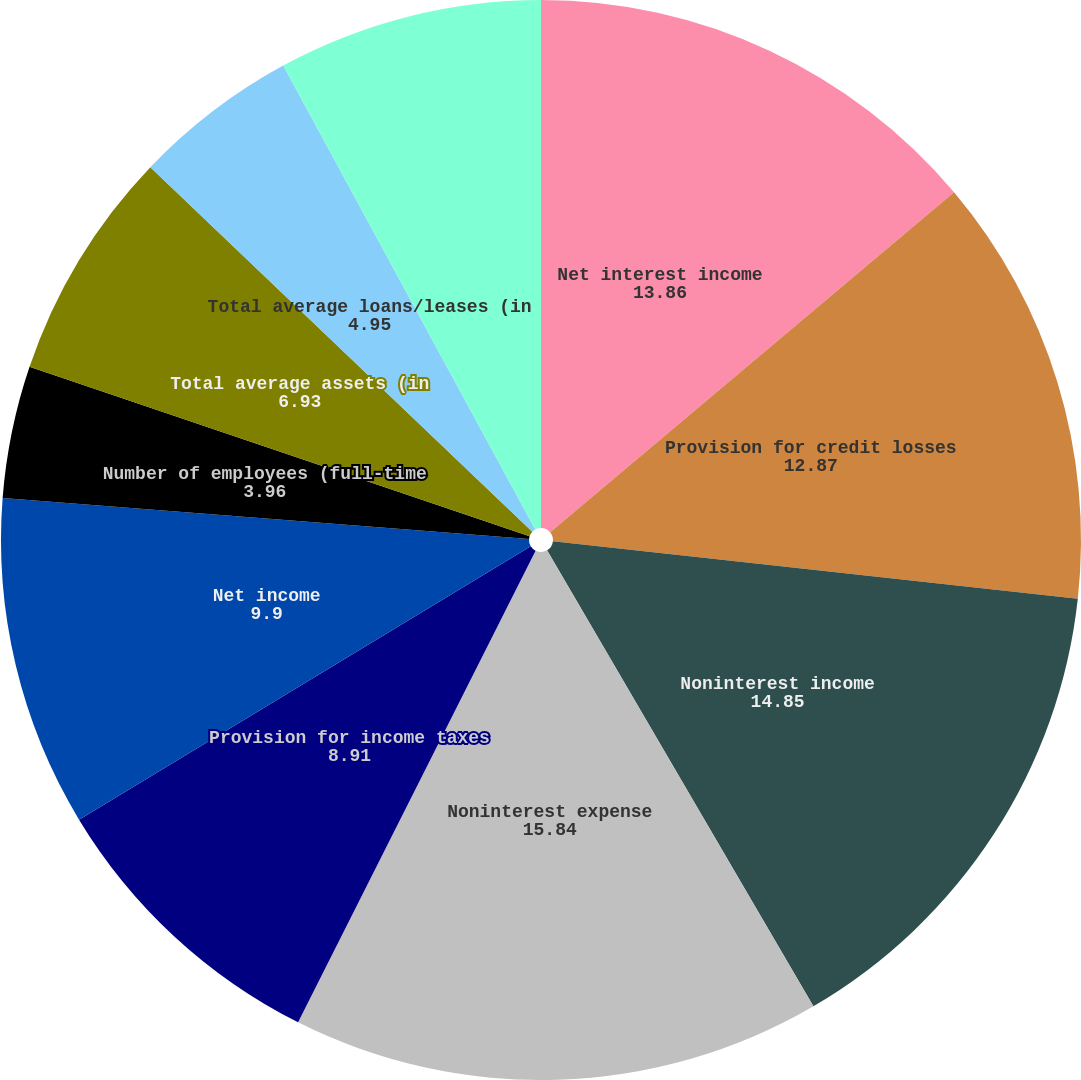Convert chart to OTSL. <chart><loc_0><loc_0><loc_500><loc_500><pie_chart><fcel>Net interest income<fcel>Provision for credit losses<fcel>Noninterest income<fcel>Noninterest expense<fcel>Provision for income taxes<fcel>Net income<fcel>Number of employees (full-time<fcel>Total average assets (in<fcel>Total average loans/leases (in<fcel>Total average deposits (in<nl><fcel>13.86%<fcel>12.87%<fcel>14.85%<fcel>15.84%<fcel>8.91%<fcel>9.9%<fcel>3.96%<fcel>6.93%<fcel>4.95%<fcel>7.92%<nl></chart> 